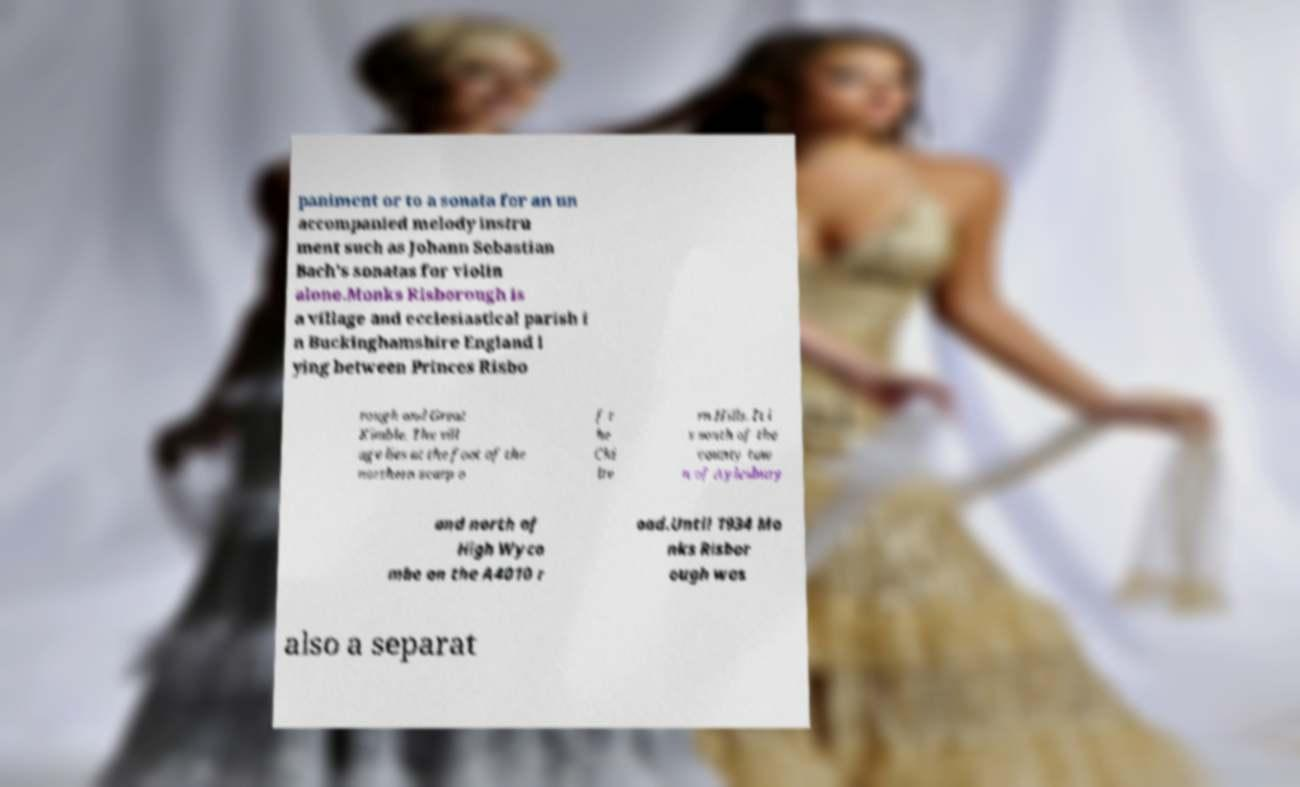Can you read and provide the text displayed in the image?This photo seems to have some interesting text. Can you extract and type it out for me? paniment or to a sonata for an un accompanied melody instru ment such as Johann Sebastian Bach’s sonatas for violin alone.Monks Risborough is a village and ecclesiastical parish i n Buckinghamshire England l ying between Princes Risbo rough and Great Kimble. The vill age lies at the foot of the northern scarp o f t he Chi lte rn Hills. It i s south of the county tow n of Aylesbury and north of High Wyco mbe on the A4010 r oad.Until 1934 Mo nks Risbor ough was also a separat 